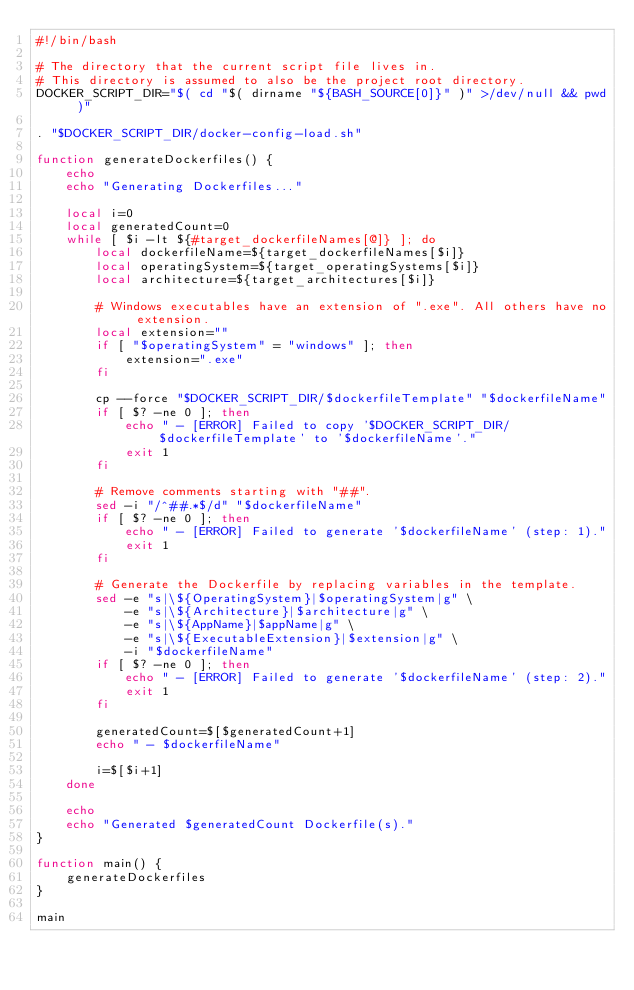Convert code to text. <code><loc_0><loc_0><loc_500><loc_500><_Bash_>#!/bin/bash

# The directory that the current script file lives in.
# This directory is assumed to also be the project root directory.
DOCKER_SCRIPT_DIR="$( cd "$( dirname "${BASH_SOURCE[0]}" )" >/dev/null && pwd )"

. "$DOCKER_SCRIPT_DIR/docker-config-load.sh"

function generateDockerfiles() {
    echo
    echo "Generating Dockerfiles..."

    local i=0
    local generatedCount=0
    while [ $i -lt ${#target_dockerfileNames[@]} ]; do
        local dockerfileName=${target_dockerfileNames[$i]}
        local operatingSystem=${target_operatingSystems[$i]}
        local architecture=${target_architectures[$i]}

        # Windows executables have an extension of ".exe". All others have no extension.
        local extension=""
        if [ "$operatingSystem" = "windows" ]; then
            extension=".exe"
        fi

        cp --force "$DOCKER_SCRIPT_DIR/$dockerfileTemplate" "$dockerfileName"
        if [ $? -ne 0 ]; then
            echo " - [ERROR] Failed to copy '$DOCKER_SCRIPT_DIR/$dockerfileTemplate' to '$dockerfileName'."
            exit 1
        fi

        # Remove comments starting with "##".
        sed -i "/^##.*$/d" "$dockerfileName"
        if [ $? -ne 0 ]; then
            echo " - [ERROR] Failed to generate '$dockerfileName' (step: 1)."
            exit 1
        fi

        # Generate the Dockerfile by replacing variables in the template.
        sed -e "s|\${OperatingSystem}|$operatingSystem|g" \
            -e "s|\${Architecture}|$architecture|g" \
            -e "s|\${AppName}|$appName|g" \
            -e "s|\${ExecutableExtension}|$extension|g" \
            -i "$dockerfileName"
        if [ $? -ne 0 ]; then
            echo " - [ERROR] Failed to generate '$dockerfileName' (step: 2)."
            exit 1
        fi

        generatedCount=$[$generatedCount+1]
        echo " - $dockerfileName"

        i=$[$i+1]
    done

    echo
    echo "Generated $generatedCount Dockerfile(s)."
}

function main() {
    generateDockerfiles
}

main
</code> 